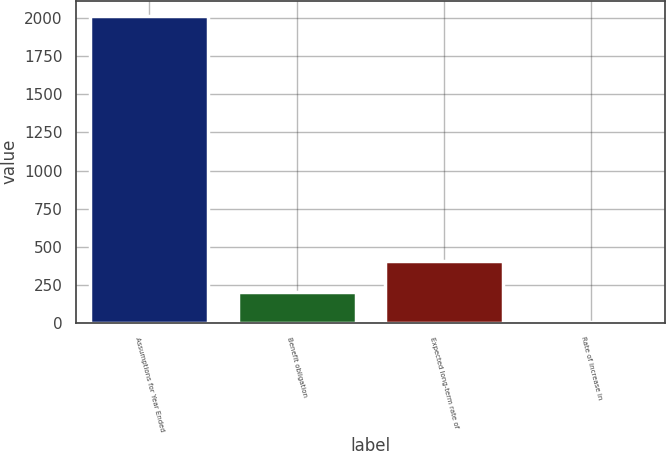Convert chart to OTSL. <chart><loc_0><loc_0><loc_500><loc_500><bar_chart><fcel>Assumptions for Year Ended<fcel>Benefit obligation<fcel>Expected long-term rate of<fcel>Rate of increase in<nl><fcel>2015<fcel>204.59<fcel>405.75<fcel>3.43<nl></chart> 